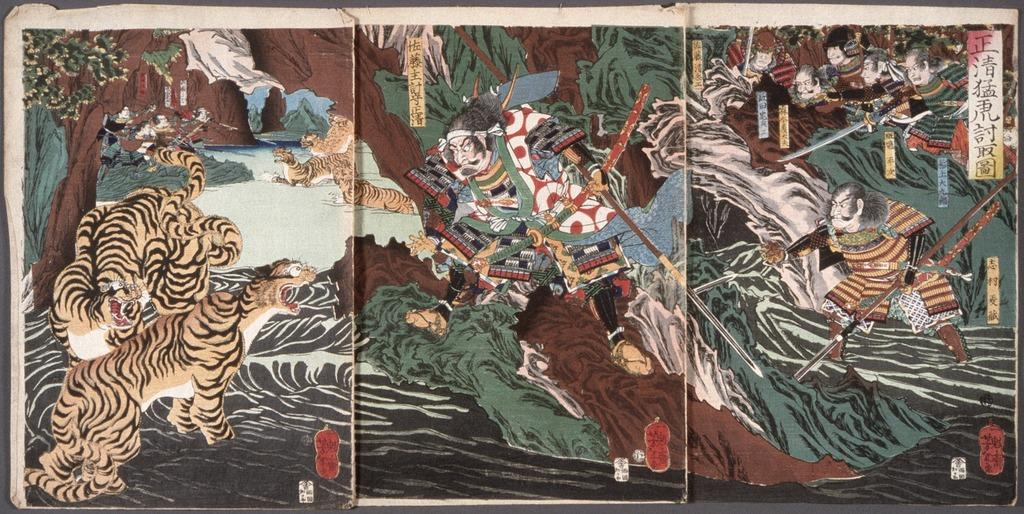What is present on the three papers in the image? The papers have images that contain people, weapons, animals, and other objects. What is the color of the object on which the papers are placed? The papers are on a black object. What type of offer can be seen in the image? There is no offer present in the image; it only contains images on papers. Where is the mailbox located in the image? There is no mailbox present in the image. 